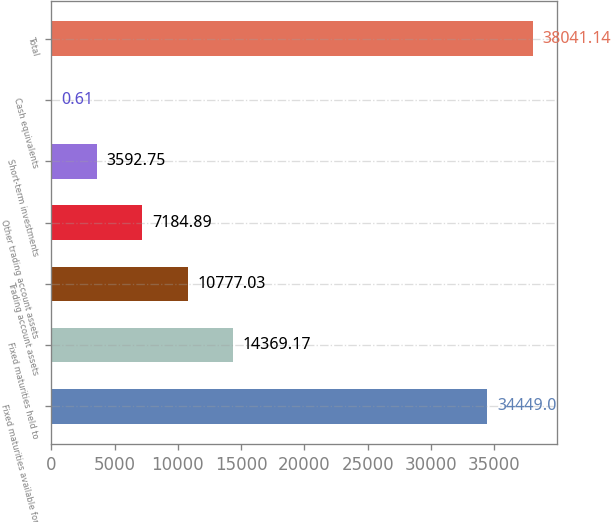<chart> <loc_0><loc_0><loc_500><loc_500><bar_chart><fcel>Fixed maturities available for<fcel>Fixed maturities held to<fcel>Trading account assets<fcel>Other trading account assets<fcel>Short-term investments<fcel>Cash equivalents<fcel>Total<nl><fcel>34449<fcel>14369.2<fcel>10777<fcel>7184.89<fcel>3592.75<fcel>0.61<fcel>38041.1<nl></chart> 